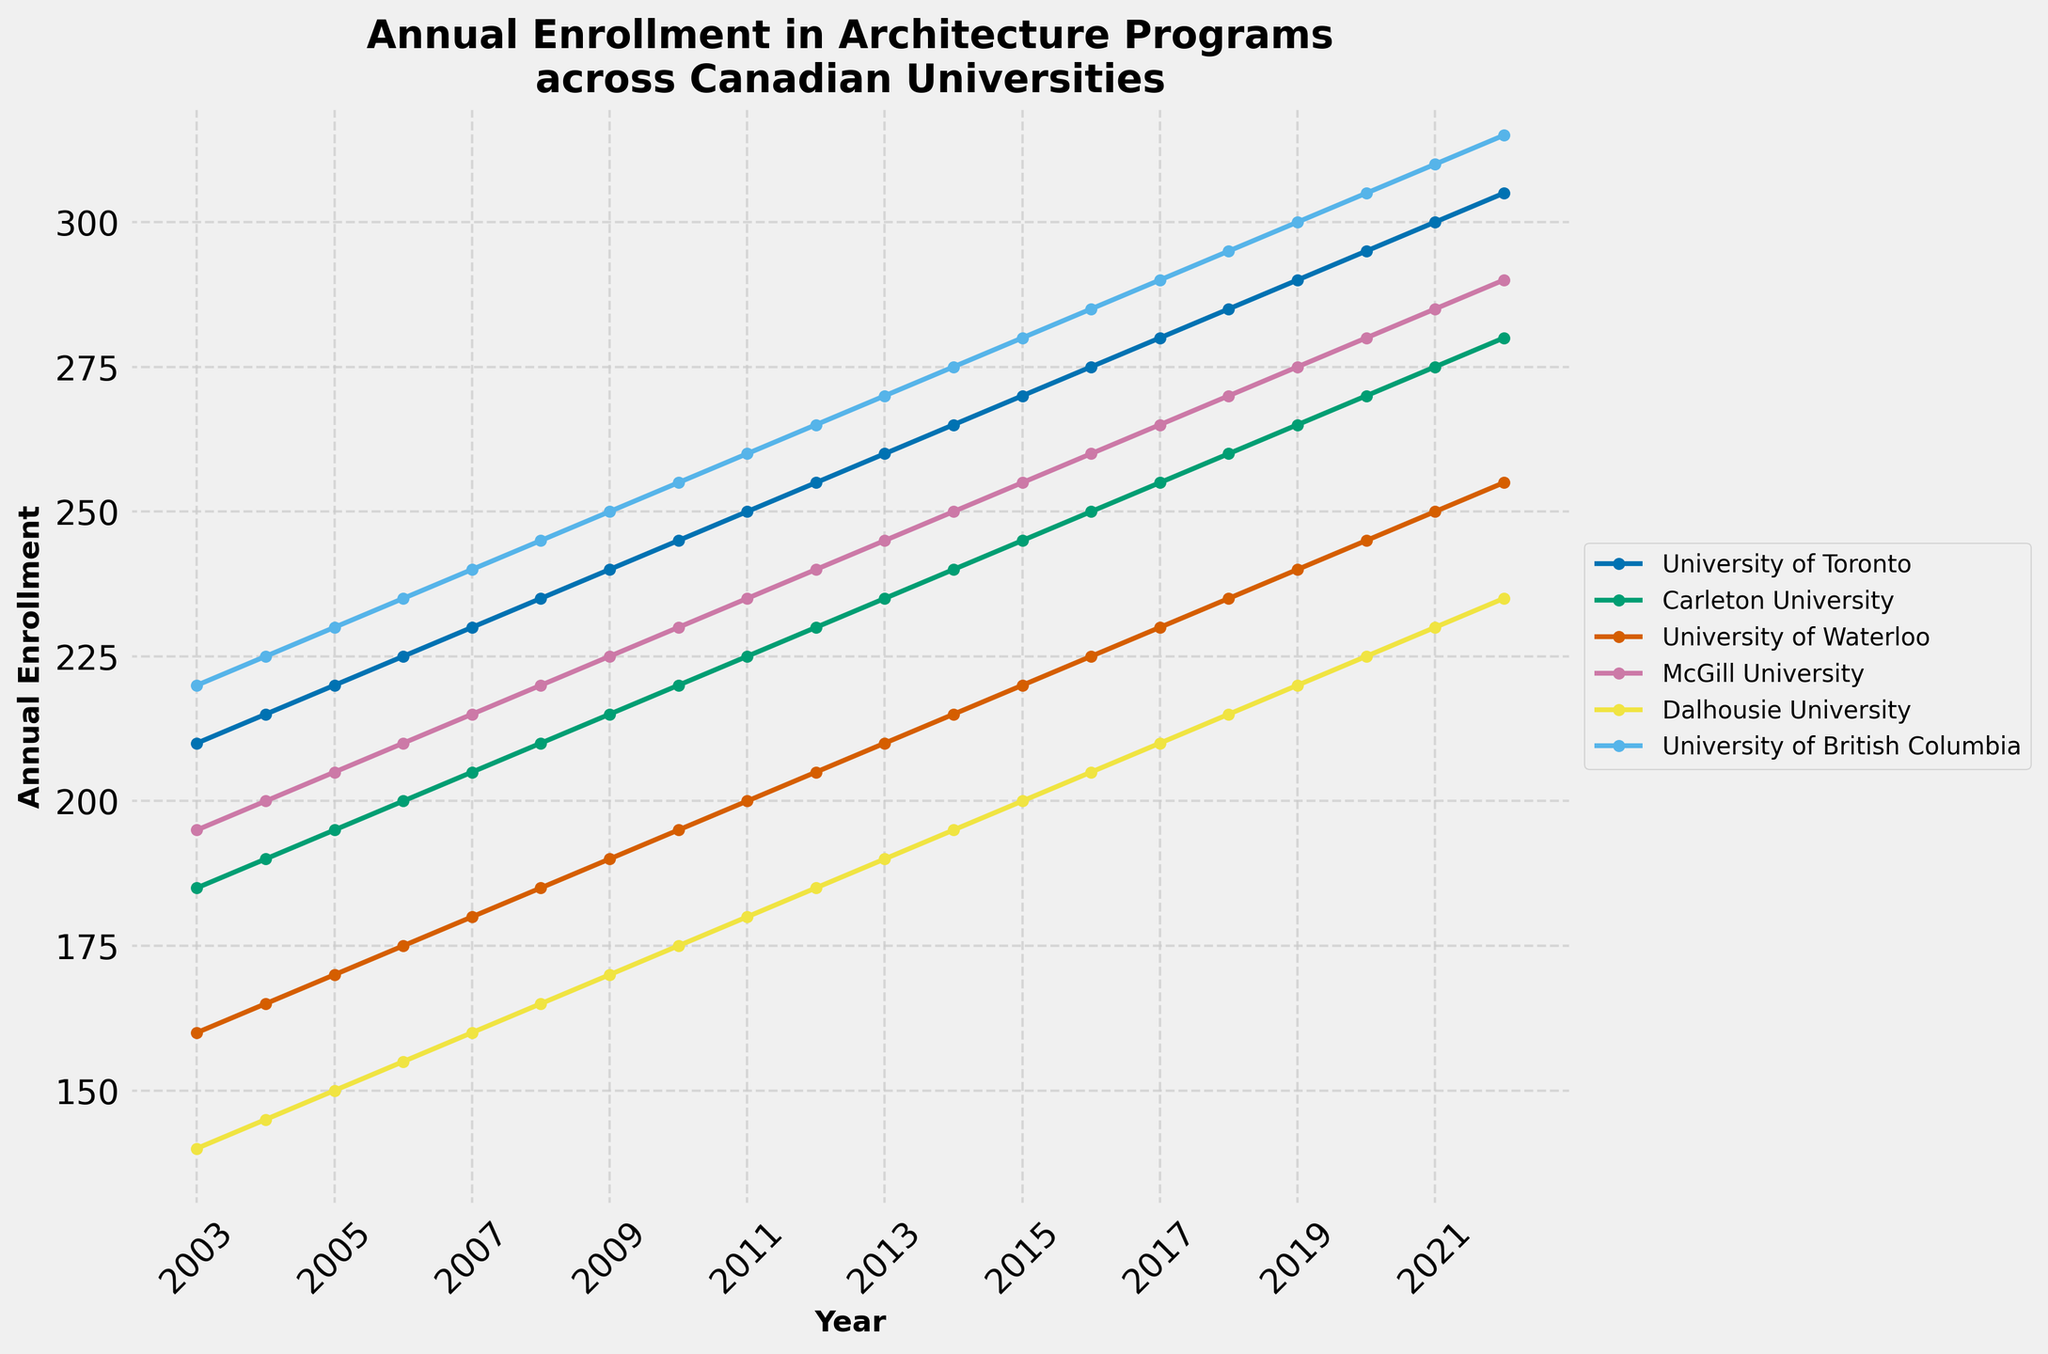What is the overall trend in annual enrollment at the University of Toronto over the 20-year period? The line for the University of Toronto consistently rises each year from 210 in 2003 to 305 in 2022, indicating a steady increase in annual enrollment.
Answer: Steady increase Which university had the highest annual enrollment in 2015? In 2015, looking at the y-values corresponding to each line, the University of British Columbia had the highest enrollment with a value of 280.
Answer: University of British Columbia How did the enrollment at McGill University compare to Carleton University in 2020? Comparing the y-values for 2020, McGill University had an enrollment of 280, while Carleton University had an enrollment of 270, meaning McGill University had higher enrollment by 10 students.
Answer: McGill University was higher by 10 students How many universities had an enrollment exceeding 250 in the year 2021? For 2021, the y-values exceed 250 for University of Toronto (300), University of British Columbia (310), University of Waterloo (250), McGill University (285), and Carleton University (275).
Answer: Five universities What is the difference in enrollment between the University of British Columbia and Dalhousie University in 2018? In 2018, the University of British Columbia had an enrollment of 295, while Dalhousie University had an enrollment of 215. The difference is 295 - 215 = 80.
Answer: 80 Between which years did Carleton University see the greatest increase in enrollment? Carleton University saw the greatest increase between consecutive years of 2020 (270) and 2021 (275), where the increase was 275 - 270 = 5 students.
Answer: 2020 and 2021 Is there any year where all the universities had increasing enrollment? Each year shows an increasing trend in enrollment compared to the previous year for all universities. This observation can be affirmed by seeing none of the lines in the graph show a decline in any particular year.
Answer: Yes What is the average annual enrollment for the University of Waterloo over the 20 years? Summing the enrollments from 2003 to 2022 [(160+165+...+255)] = 4175. Dividing this by 20 years gives an average of 4175 / 20 = 208.75.
Answer: 208.75 How does the visual style of the plot help in understanding the data? The use of different colored lines and markers for each university helps clearly distinguish them. Grid lines aid in easily interpreting values, and the consistent increase in markers helps identify trends at a glance.
Answer: Clear distinction, ease of interpretation Did any university have a period of stagnant enrollment? None of the universities show a period where enrollment stalls or remains flat. All lines demonstrate a yearly increase.
Answer: No 